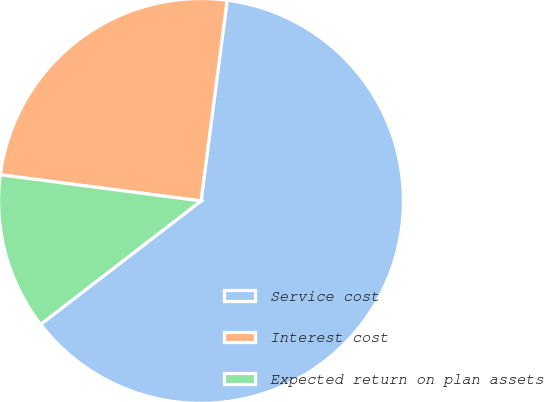Convert chart. <chart><loc_0><loc_0><loc_500><loc_500><pie_chart><fcel>Service cost<fcel>Interest cost<fcel>Expected return on plan assets<nl><fcel>62.5%<fcel>25.0%<fcel>12.5%<nl></chart> 